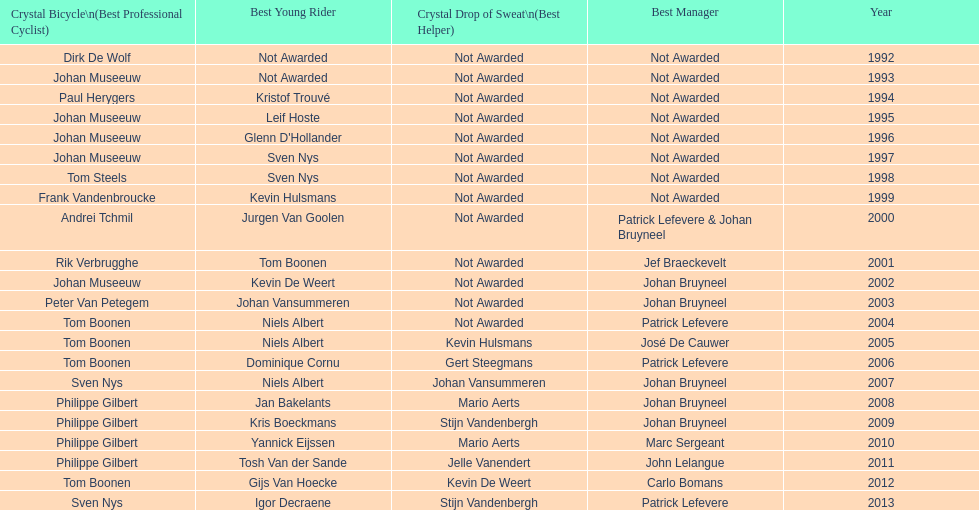Who won the crystal bicycle earlier, boonen or nys? Tom Boonen. 